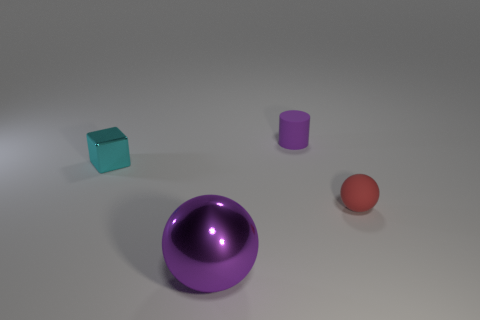What material is the cube?
Your answer should be very brief. Metal. Are there any big cyan cubes?
Offer a terse response. No. There is a tiny thing that is right of the purple matte thing; what is its color?
Offer a very short reply. Red. There is a tiny cyan block to the left of the thing in front of the small red rubber sphere; what number of shiny objects are to the left of it?
Offer a very short reply. 0. There is a thing that is both in front of the small block and to the right of the big ball; what material is it made of?
Your answer should be compact. Rubber. Do the small red object and the purple object that is to the left of the small purple rubber cylinder have the same material?
Offer a very short reply. No. Are there more tiny purple matte objects that are in front of the tiny cylinder than objects on the right side of the metallic block?
Provide a succinct answer. No. What is the shape of the red thing?
Provide a short and direct response. Sphere. Is the ball left of the tiny red thing made of the same material as the purple object behind the tiny rubber sphere?
Make the answer very short. No. What shape is the purple object that is in front of the small cyan cube?
Your answer should be compact. Sphere. 